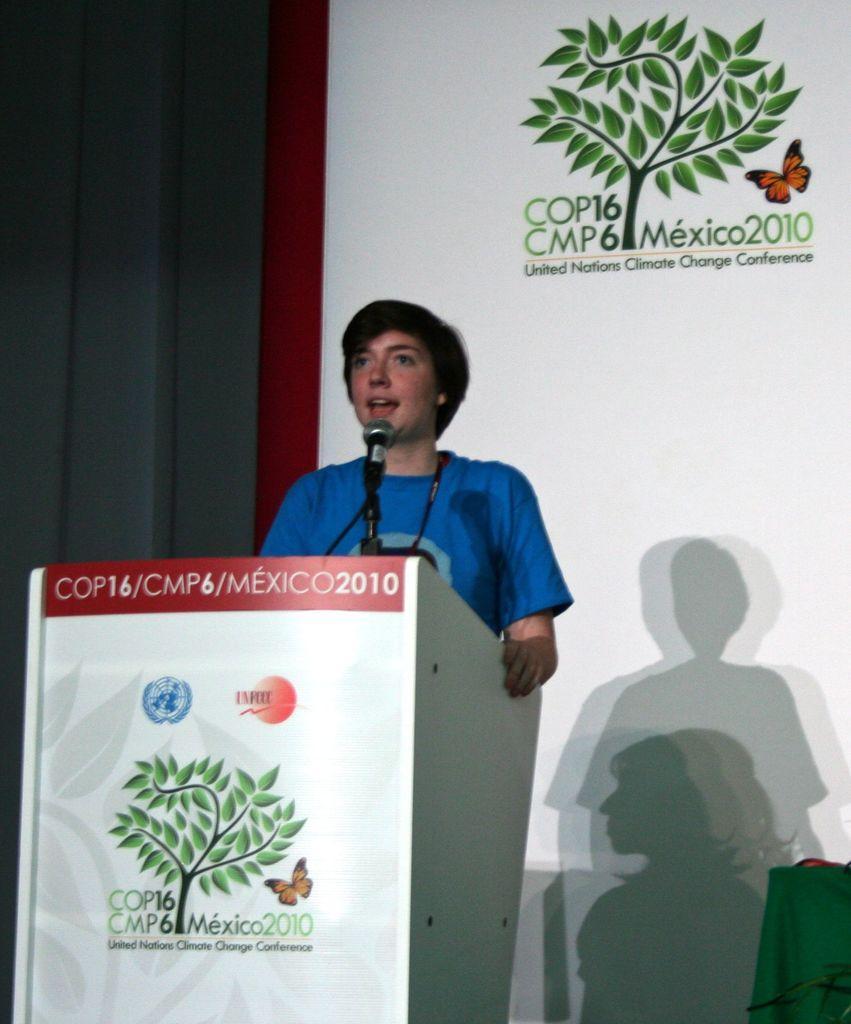How would you summarize this image in a sentence or two? In this image I see a man who is wearing blue t-shirt and I see that he is standing in front of a podium on which there is a mic and I see words and numbers written and in the background I see the poster on which there is a depiction of a tree and a butterfly over here and I see few words and numbers over here too and I see the depiction of a tree and a butterfly over here too. 